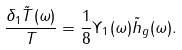<formula> <loc_0><loc_0><loc_500><loc_500>\frac { \delta _ { 1 } \tilde { T } ( \omega ) } { T } = \frac { 1 } { 8 } \Upsilon _ { 1 } ( \omega ) \tilde { h } _ { g } ( \omega ) .</formula> 